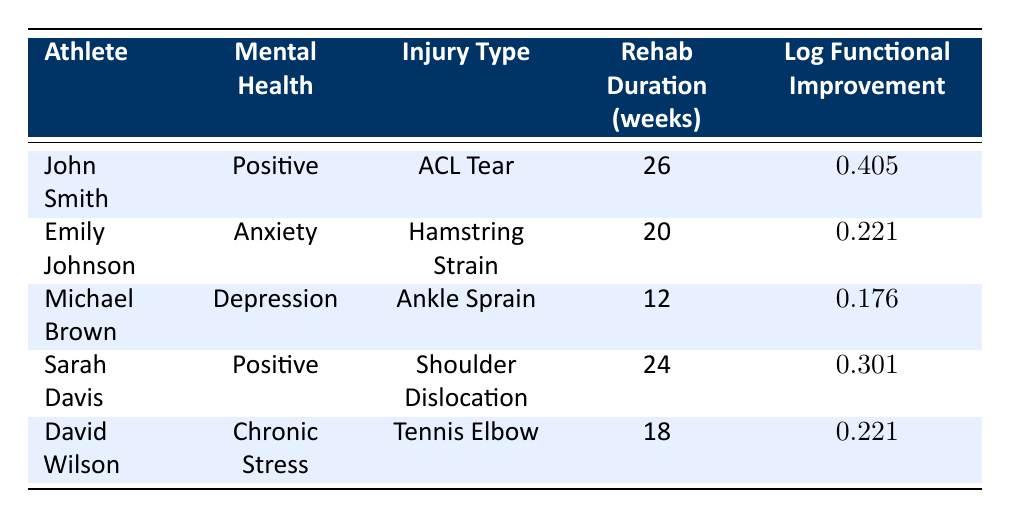What is the rehabilitation duration of Emily Johnson? Emily Johnson's rehabilitation duration is listed in the table under "Rehab Duration (weeks)" which corresponds to her entry. The value provided is 20 weeks.
Answer: 20 weeks Which athlete reported the highest log functional improvement? To find the athlete with the highest log functional improvement, compare the values in the "Log Functional Improvement" column. John Smith has a value of 0.405, which is higher than the others.
Answer: John Smith What is the average rehabilitation duration of athletes with a positive mental health status? The athletes with a positive mental health status are John Smith and Sarah Davis. Their rehab durations are 26 weeks and 24 weeks, respectively. Adding these gives 26 + 24 = 50 weeks. Dividing by the number of athletes (2) yields an average of 50/2 = 25 weeks.
Answer: 25 weeks Is there an athlete with both a positive mental health status and a lower log functional improvement than Michael Brown? Michael Brown has a log functional improvement of 0.176. Among athletes with positive mental health (John Smith and Sarah Davis), John's improvement is 0.405 and Sarah's is 0.301, both of which are higher than Michael's. Therefore, there are no positive mental health athletes with a lower improvement.
Answer: No What is the difference in log functional improvement between the athlete with chronic stress and the athlete with depression? The athlete with chronic stress (David Wilson) has a log functional improvement of 0.221, while the athlete with depression (Michael Brown) has 0.176. The difference is calculated as 0.221 - 0.176 = 0.045.
Answer: 0.045 How many athletes have an anxiety or chronic stress mental health status? The athletes with anxiety include Emily Johnson and with chronic stress is David Wilson. This totals to 2 athletes when counting both types.
Answer: 2 athletes Which injury type has the shortest rehabilitation duration? The injury types and their corresponding rehabilitation durations are listed. Michael Brown's ankle sprain has the shortest duration at 12 weeks compared to the others.
Answer: Ankle Sprain What percentage of athletes have a log functional improvement higher than 0.25? Athletes with a log functional improvement higher than 0.25 are John Smith (0.405) and Sarah Davis (0.301), making 2 out of 5 total athletes. Thus, the percentage is (2/5) * 100 = 40%.
Answer: 40% 